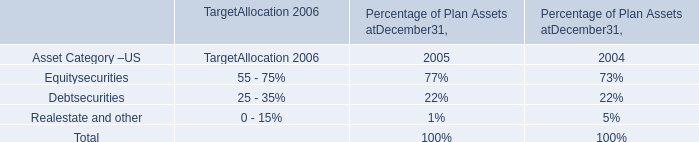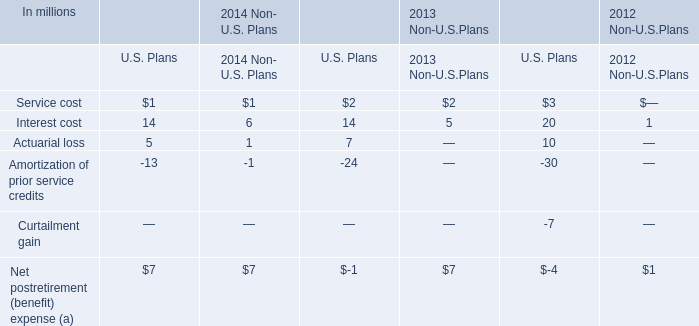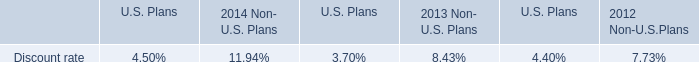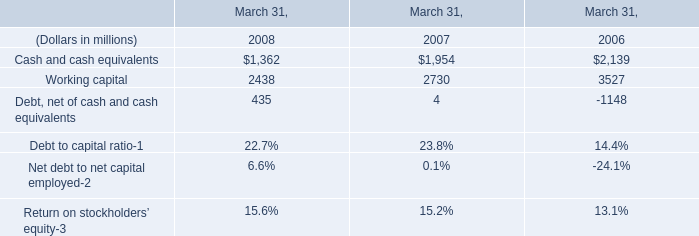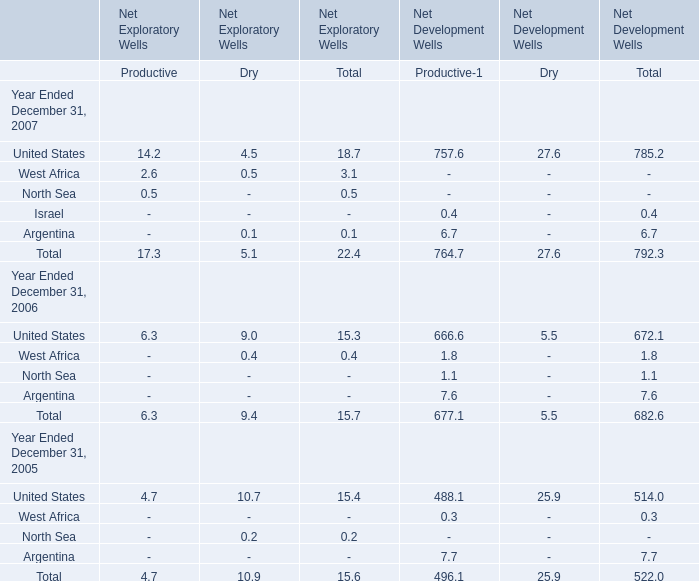Which year is the amount of the total Net Exploratory Wells in terms of Dry the least? 
Answer: 2007. 